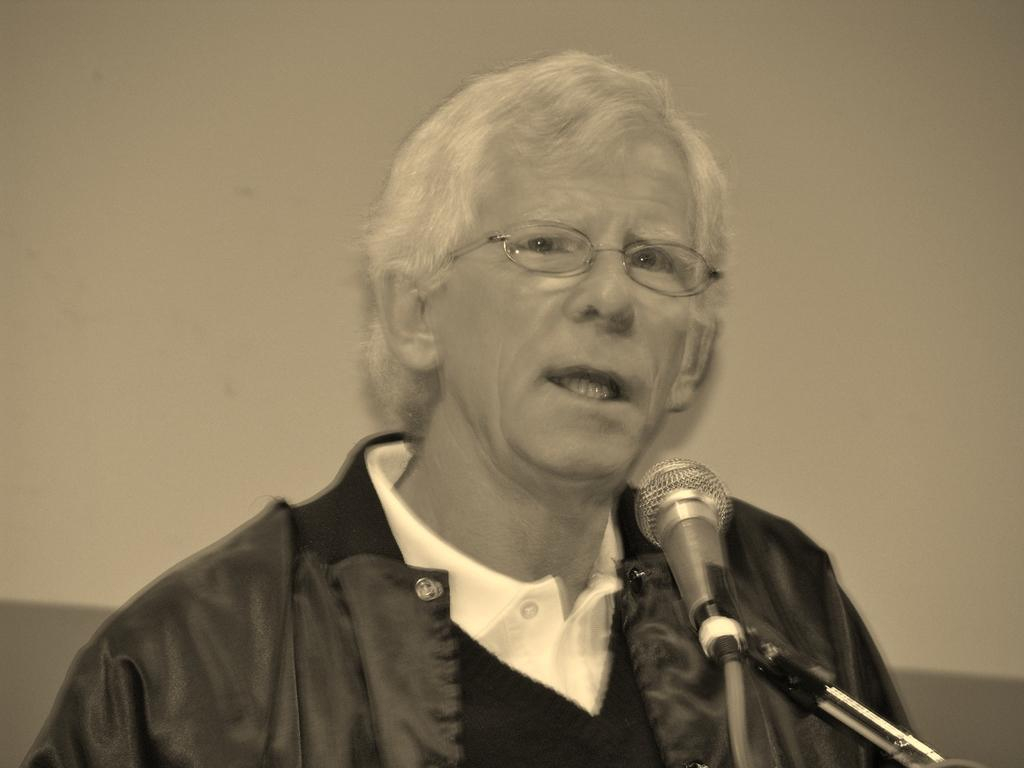Who or what is in the image? There is a person in the image. What is the person doing or interacting with in the image? The person is in front of a microphone with a stand. What can be seen behind the person? There is a wall behind the person. What type of camera is the person holding in the image? There is no camera present in the image; the person is interacting with a microphone with a stand. In which direction is the person facing in the image? The direction the person is facing cannot be determined from the image alone, as we cannot see the person's full body or any other reference points. 